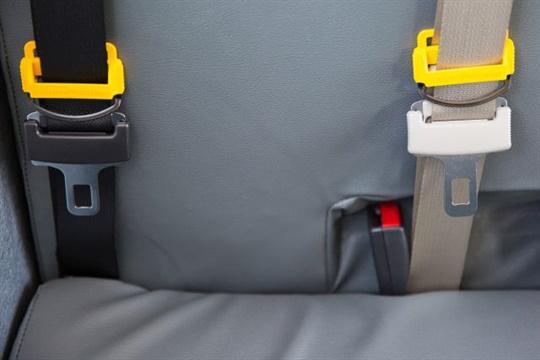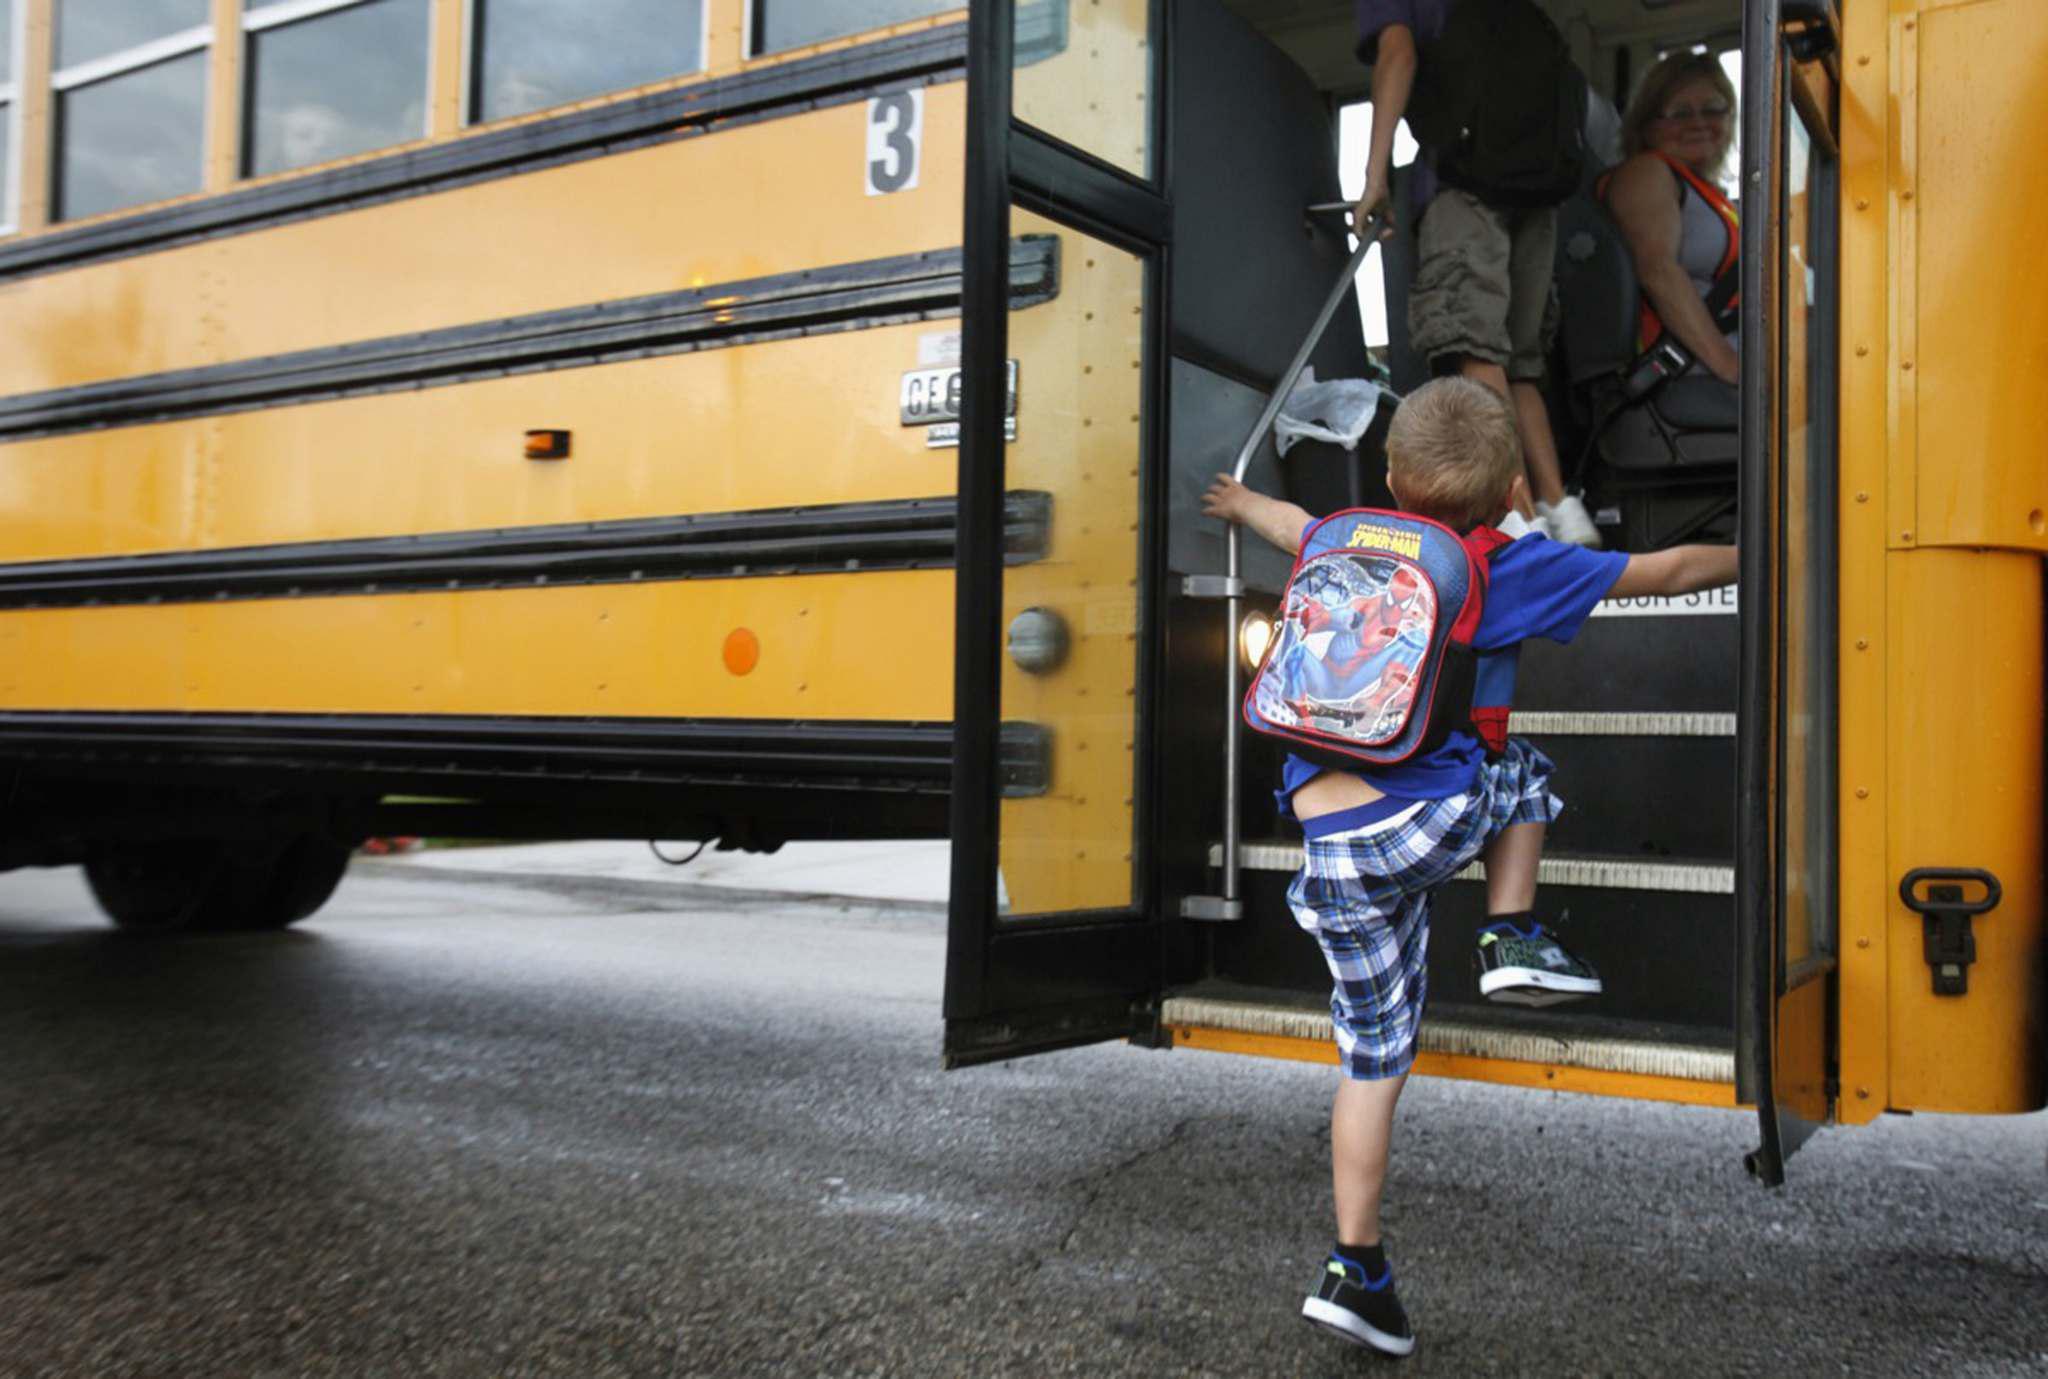The first image is the image on the left, the second image is the image on the right. Considering the images on both sides, is "The left image shows an empty gray seat with two seat buckles and straps on the seat back." valid? Answer yes or no. Yes. The first image is the image on the left, the second image is the image on the right. For the images shown, is this caption "In one of the images only the seat belts are shown." true? Answer yes or no. Yes. 